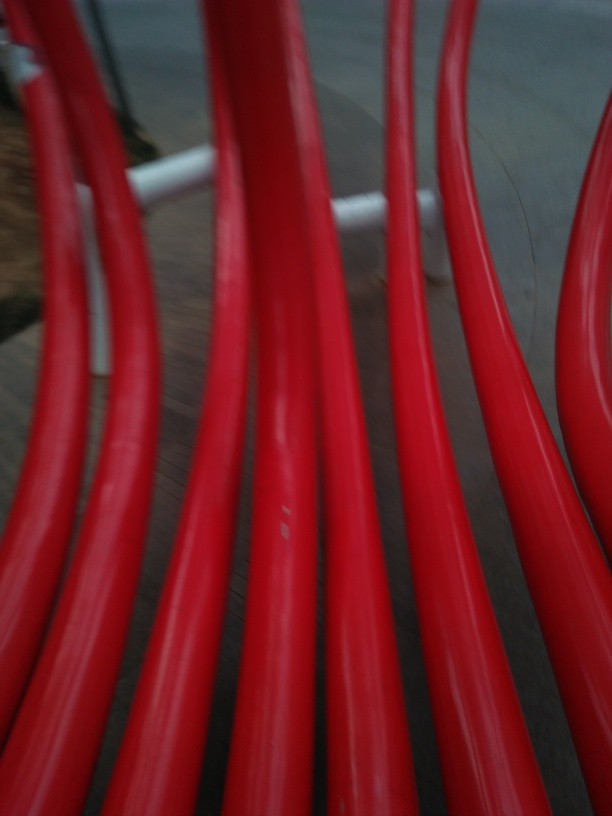What suggestions might improve the quality of such an image? To improve the image quality and achieve a clear shot, it would be advisable to ensure the camera focuses correctly on the subject. This might require manually adjusting the focus or steadying the camera to prevent motion blur. Utilizing a faster shutter speed can also help freeze motion, especially if the subject is moving quickly or if you're shooting without a tripod. 